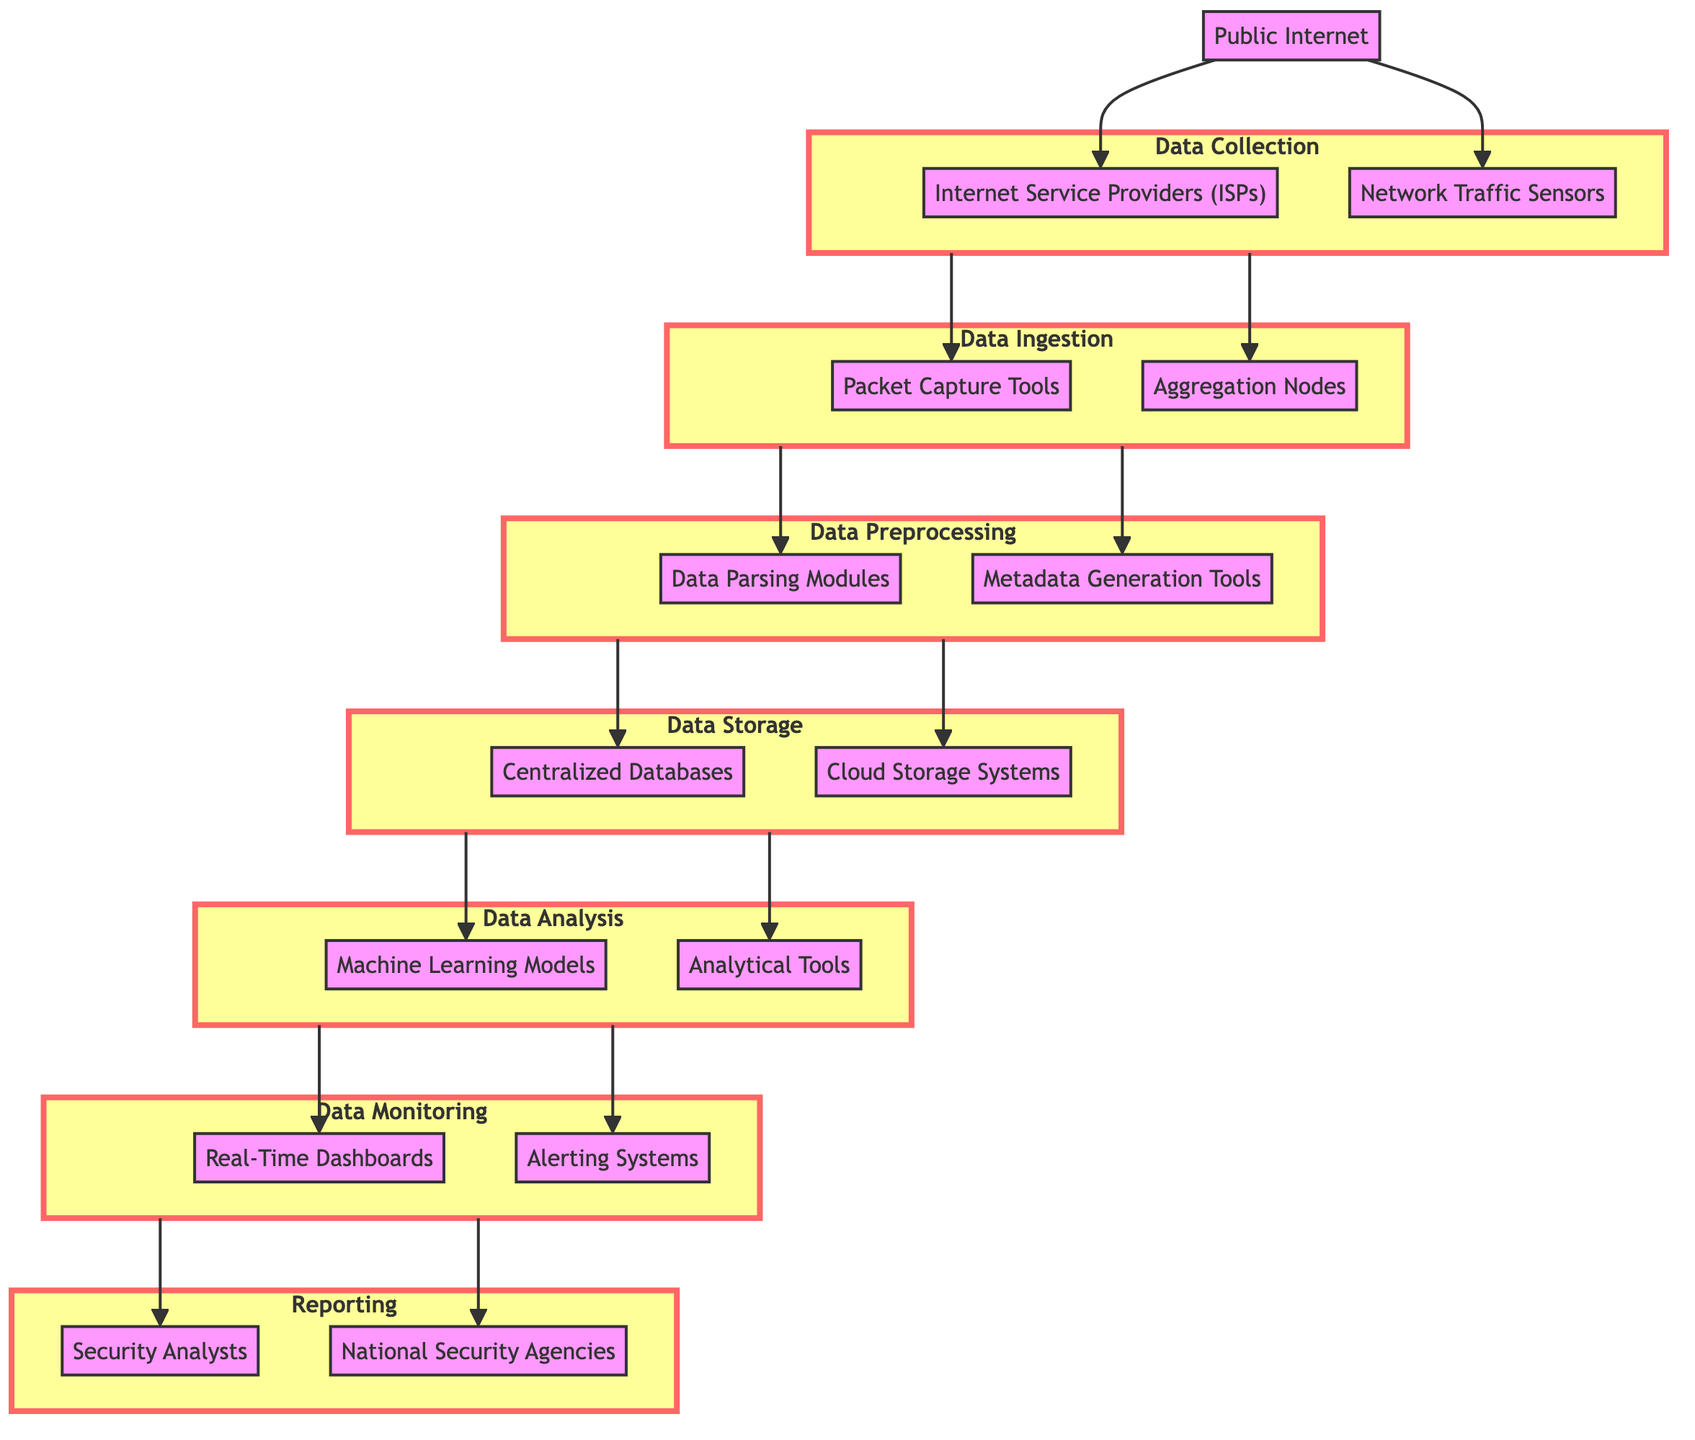What are the three entities involved in the Data Collection stage? The entities involved in the Data Collection stage, as represented in the diagram, are listed under that stage, which includes "Public Internet," "Internet Service Providers (ISPs)," and "Network Traffic Sensors."
Answer: Public Internet, Internet Service Providers, Network Traffic Sensors How many stages are there in the data flow process? To find the number of stages, I can count each unique subgraph or section labeled in the flowchart. There are seven subgraphs labeled are Data Collection, Data Ingestion, Data Preprocessing, Data Storage, Data Analysis, Data Monitoring, and Reporting.
Answer: Seven What directly follows Data Storage in the flowchart? By observing the flowchart, I can see that Data Storage connects directly to Data Analysis. This implies that the output of Data Storage is passed on to the Data Analysis stage.
Answer: Data Analysis What tools are used in the Data Ingestion stage? In the Data Ingestion stage, the diagram indicates that "Packet Capture Tools" and "Aggregation Nodes" are the tools used. These tools are specifically mentioned within that subgraph in the diagram.
Answer: Packet Capture Tools, Aggregation Nodes Which entities monitor data for suspicious activities? The entities involved in monitoring data for suspicious activities are specified in the Data Monitoring stage. Here, "Real-Time Dashboards" and "Alerting Systems" are identified as the monitoring entities.
Answer: Real-Time Dashboards, Alerting Systems What is the purpose of the Data Preprocessing stage? The purpose of the Data Preprocessing stage can be inferred from its description in the diagram, which states that this stage involves "Data Parsing Modules" and "Metadata Generation Tools" to make data easier for analysis.
Answer: Easier analysis Which stage comes immediately before Reporting? To find the stage preceding Reporting, I can trace the flow upwards in the diagram. The Data Monitoring stage comes directly before Reporting in the flowchart's structure.
Answer: Data Monitoring How do findings from the analysis reach National Security Agencies? Findings from the analysis are forwarded from the Data Monitoring stage, as indicated by the flowchart, reaching both "Security Analysts" and "National Security Agencies" together in the Reporting stage.
Answer: Through Reporting What is the relationship between Data Analysis and Data Monitoring? The flowchart shows that Data Analysis leads directly to Data Monitoring, indicating that the results or outputs produced during Data Analysis are the inputs monitored for suspicious activities in the subsequent stage.
Answer: Data Analysis leads to Data Monitoring 